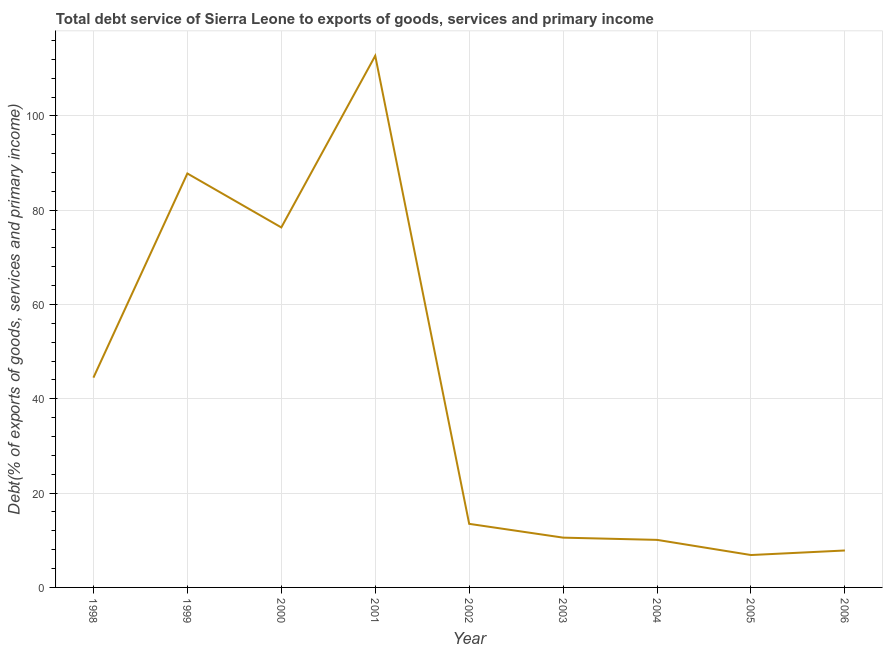What is the total debt service in 1999?
Your answer should be compact. 87.79. Across all years, what is the maximum total debt service?
Offer a very short reply. 112.75. Across all years, what is the minimum total debt service?
Make the answer very short. 6.87. In which year was the total debt service minimum?
Keep it short and to the point. 2005. What is the sum of the total debt service?
Make the answer very short. 370.23. What is the difference between the total debt service in 2002 and 2005?
Provide a short and direct response. 6.61. What is the average total debt service per year?
Keep it short and to the point. 41.14. What is the median total debt service?
Your answer should be compact. 13.48. What is the ratio of the total debt service in 1998 to that in 2006?
Your answer should be very brief. 5.68. What is the difference between the highest and the second highest total debt service?
Offer a terse response. 24.96. What is the difference between the highest and the lowest total debt service?
Your answer should be compact. 105.88. Does the total debt service monotonically increase over the years?
Your answer should be very brief. No. Are the values on the major ticks of Y-axis written in scientific E-notation?
Keep it short and to the point. No. Does the graph contain grids?
Give a very brief answer. Yes. What is the title of the graph?
Provide a succinct answer. Total debt service of Sierra Leone to exports of goods, services and primary income. What is the label or title of the Y-axis?
Your answer should be compact. Debt(% of exports of goods, services and primary income). What is the Debt(% of exports of goods, services and primary income) in 1998?
Your response must be concise. 44.49. What is the Debt(% of exports of goods, services and primary income) in 1999?
Offer a terse response. 87.79. What is the Debt(% of exports of goods, services and primary income) of 2000?
Your answer should be compact. 76.35. What is the Debt(% of exports of goods, services and primary income) in 2001?
Offer a very short reply. 112.75. What is the Debt(% of exports of goods, services and primary income) of 2002?
Your response must be concise. 13.48. What is the Debt(% of exports of goods, services and primary income) in 2003?
Keep it short and to the point. 10.56. What is the Debt(% of exports of goods, services and primary income) of 2004?
Keep it short and to the point. 10.09. What is the Debt(% of exports of goods, services and primary income) in 2005?
Your response must be concise. 6.87. What is the Debt(% of exports of goods, services and primary income) of 2006?
Offer a very short reply. 7.84. What is the difference between the Debt(% of exports of goods, services and primary income) in 1998 and 1999?
Ensure brevity in your answer.  -43.3. What is the difference between the Debt(% of exports of goods, services and primary income) in 1998 and 2000?
Provide a succinct answer. -31.86. What is the difference between the Debt(% of exports of goods, services and primary income) in 1998 and 2001?
Give a very brief answer. -68.26. What is the difference between the Debt(% of exports of goods, services and primary income) in 1998 and 2002?
Make the answer very short. 31.01. What is the difference between the Debt(% of exports of goods, services and primary income) in 1998 and 2003?
Make the answer very short. 33.93. What is the difference between the Debt(% of exports of goods, services and primary income) in 1998 and 2004?
Give a very brief answer. 34.41. What is the difference between the Debt(% of exports of goods, services and primary income) in 1998 and 2005?
Your answer should be compact. 37.62. What is the difference between the Debt(% of exports of goods, services and primary income) in 1998 and 2006?
Provide a short and direct response. 36.66. What is the difference between the Debt(% of exports of goods, services and primary income) in 1999 and 2000?
Provide a short and direct response. 11.44. What is the difference between the Debt(% of exports of goods, services and primary income) in 1999 and 2001?
Your answer should be compact. -24.96. What is the difference between the Debt(% of exports of goods, services and primary income) in 1999 and 2002?
Make the answer very short. 74.31. What is the difference between the Debt(% of exports of goods, services and primary income) in 1999 and 2003?
Your response must be concise. 77.23. What is the difference between the Debt(% of exports of goods, services and primary income) in 1999 and 2004?
Ensure brevity in your answer.  77.71. What is the difference between the Debt(% of exports of goods, services and primary income) in 1999 and 2005?
Give a very brief answer. 80.92. What is the difference between the Debt(% of exports of goods, services and primary income) in 1999 and 2006?
Make the answer very short. 79.96. What is the difference between the Debt(% of exports of goods, services and primary income) in 2000 and 2001?
Offer a terse response. -36.4. What is the difference between the Debt(% of exports of goods, services and primary income) in 2000 and 2002?
Your response must be concise. 62.87. What is the difference between the Debt(% of exports of goods, services and primary income) in 2000 and 2003?
Your response must be concise. 65.79. What is the difference between the Debt(% of exports of goods, services and primary income) in 2000 and 2004?
Your response must be concise. 66.27. What is the difference between the Debt(% of exports of goods, services and primary income) in 2000 and 2005?
Make the answer very short. 69.48. What is the difference between the Debt(% of exports of goods, services and primary income) in 2000 and 2006?
Your answer should be compact. 68.52. What is the difference between the Debt(% of exports of goods, services and primary income) in 2001 and 2002?
Make the answer very short. 99.27. What is the difference between the Debt(% of exports of goods, services and primary income) in 2001 and 2003?
Your answer should be compact. 102.19. What is the difference between the Debt(% of exports of goods, services and primary income) in 2001 and 2004?
Offer a very short reply. 102.67. What is the difference between the Debt(% of exports of goods, services and primary income) in 2001 and 2005?
Give a very brief answer. 105.88. What is the difference between the Debt(% of exports of goods, services and primary income) in 2001 and 2006?
Give a very brief answer. 104.92. What is the difference between the Debt(% of exports of goods, services and primary income) in 2002 and 2003?
Give a very brief answer. 2.93. What is the difference between the Debt(% of exports of goods, services and primary income) in 2002 and 2004?
Ensure brevity in your answer.  3.4. What is the difference between the Debt(% of exports of goods, services and primary income) in 2002 and 2005?
Provide a short and direct response. 6.61. What is the difference between the Debt(% of exports of goods, services and primary income) in 2002 and 2006?
Give a very brief answer. 5.65. What is the difference between the Debt(% of exports of goods, services and primary income) in 2003 and 2004?
Provide a succinct answer. 0.47. What is the difference between the Debt(% of exports of goods, services and primary income) in 2003 and 2005?
Your response must be concise. 3.69. What is the difference between the Debt(% of exports of goods, services and primary income) in 2003 and 2006?
Keep it short and to the point. 2.72. What is the difference between the Debt(% of exports of goods, services and primary income) in 2004 and 2005?
Ensure brevity in your answer.  3.22. What is the difference between the Debt(% of exports of goods, services and primary income) in 2004 and 2006?
Your response must be concise. 2.25. What is the difference between the Debt(% of exports of goods, services and primary income) in 2005 and 2006?
Make the answer very short. -0.97. What is the ratio of the Debt(% of exports of goods, services and primary income) in 1998 to that in 1999?
Make the answer very short. 0.51. What is the ratio of the Debt(% of exports of goods, services and primary income) in 1998 to that in 2000?
Provide a succinct answer. 0.58. What is the ratio of the Debt(% of exports of goods, services and primary income) in 1998 to that in 2001?
Make the answer very short. 0.4. What is the ratio of the Debt(% of exports of goods, services and primary income) in 1998 to that in 2002?
Keep it short and to the point. 3.3. What is the ratio of the Debt(% of exports of goods, services and primary income) in 1998 to that in 2003?
Make the answer very short. 4.21. What is the ratio of the Debt(% of exports of goods, services and primary income) in 1998 to that in 2004?
Provide a short and direct response. 4.41. What is the ratio of the Debt(% of exports of goods, services and primary income) in 1998 to that in 2005?
Your response must be concise. 6.48. What is the ratio of the Debt(% of exports of goods, services and primary income) in 1998 to that in 2006?
Your response must be concise. 5.68. What is the ratio of the Debt(% of exports of goods, services and primary income) in 1999 to that in 2000?
Provide a short and direct response. 1.15. What is the ratio of the Debt(% of exports of goods, services and primary income) in 1999 to that in 2001?
Provide a short and direct response. 0.78. What is the ratio of the Debt(% of exports of goods, services and primary income) in 1999 to that in 2002?
Give a very brief answer. 6.51. What is the ratio of the Debt(% of exports of goods, services and primary income) in 1999 to that in 2003?
Provide a short and direct response. 8.31. What is the ratio of the Debt(% of exports of goods, services and primary income) in 1999 to that in 2004?
Give a very brief answer. 8.7. What is the ratio of the Debt(% of exports of goods, services and primary income) in 1999 to that in 2005?
Offer a terse response. 12.78. What is the ratio of the Debt(% of exports of goods, services and primary income) in 1999 to that in 2006?
Provide a succinct answer. 11.21. What is the ratio of the Debt(% of exports of goods, services and primary income) in 2000 to that in 2001?
Keep it short and to the point. 0.68. What is the ratio of the Debt(% of exports of goods, services and primary income) in 2000 to that in 2002?
Keep it short and to the point. 5.66. What is the ratio of the Debt(% of exports of goods, services and primary income) in 2000 to that in 2003?
Ensure brevity in your answer.  7.23. What is the ratio of the Debt(% of exports of goods, services and primary income) in 2000 to that in 2004?
Provide a short and direct response. 7.57. What is the ratio of the Debt(% of exports of goods, services and primary income) in 2000 to that in 2005?
Give a very brief answer. 11.11. What is the ratio of the Debt(% of exports of goods, services and primary income) in 2000 to that in 2006?
Provide a succinct answer. 9.74. What is the ratio of the Debt(% of exports of goods, services and primary income) in 2001 to that in 2002?
Your answer should be compact. 8.36. What is the ratio of the Debt(% of exports of goods, services and primary income) in 2001 to that in 2003?
Your answer should be compact. 10.68. What is the ratio of the Debt(% of exports of goods, services and primary income) in 2001 to that in 2004?
Offer a terse response. 11.18. What is the ratio of the Debt(% of exports of goods, services and primary income) in 2001 to that in 2005?
Give a very brief answer. 16.41. What is the ratio of the Debt(% of exports of goods, services and primary income) in 2001 to that in 2006?
Provide a short and direct response. 14.39. What is the ratio of the Debt(% of exports of goods, services and primary income) in 2002 to that in 2003?
Give a very brief answer. 1.28. What is the ratio of the Debt(% of exports of goods, services and primary income) in 2002 to that in 2004?
Your response must be concise. 1.34. What is the ratio of the Debt(% of exports of goods, services and primary income) in 2002 to that in 2005?
Your answer should be very brief. 1.96. What is the ratio of the Debt(% of exports of goods, services and primary income) in 2002 to that in 2006?
Provide a succinct answer. 1.72. What is the ratio of the Debt(% of exports of goods, services and primary income) in 2003 to that in 2004?
Make the answer very short. 1.05. What is the ratio of the Debt(% of exports of goods, services and primary income) in 2003 to that in 2005?
Your answer should be very brief. 1.54. What is the ratio of the Debt(% of exports of goods, services and primary income) in 2003 to that in 2006?
Ensure brevity in your answer.  1.35. What is the ratio of the Debt(% of exports of goods, services and primary income) in 2004 to that in 2005?
Offer a terse response. 1.47. What is the ratio of the Debt(% of exports of goods, services and primary income) in 2004 to that in 2006?
Offer a very short reply. 1.29. What is the ratio of the Debt(% of exports of goods, services and primary income) in 2005 to that in 2006?
Provide a succinct answer. 0.88. 